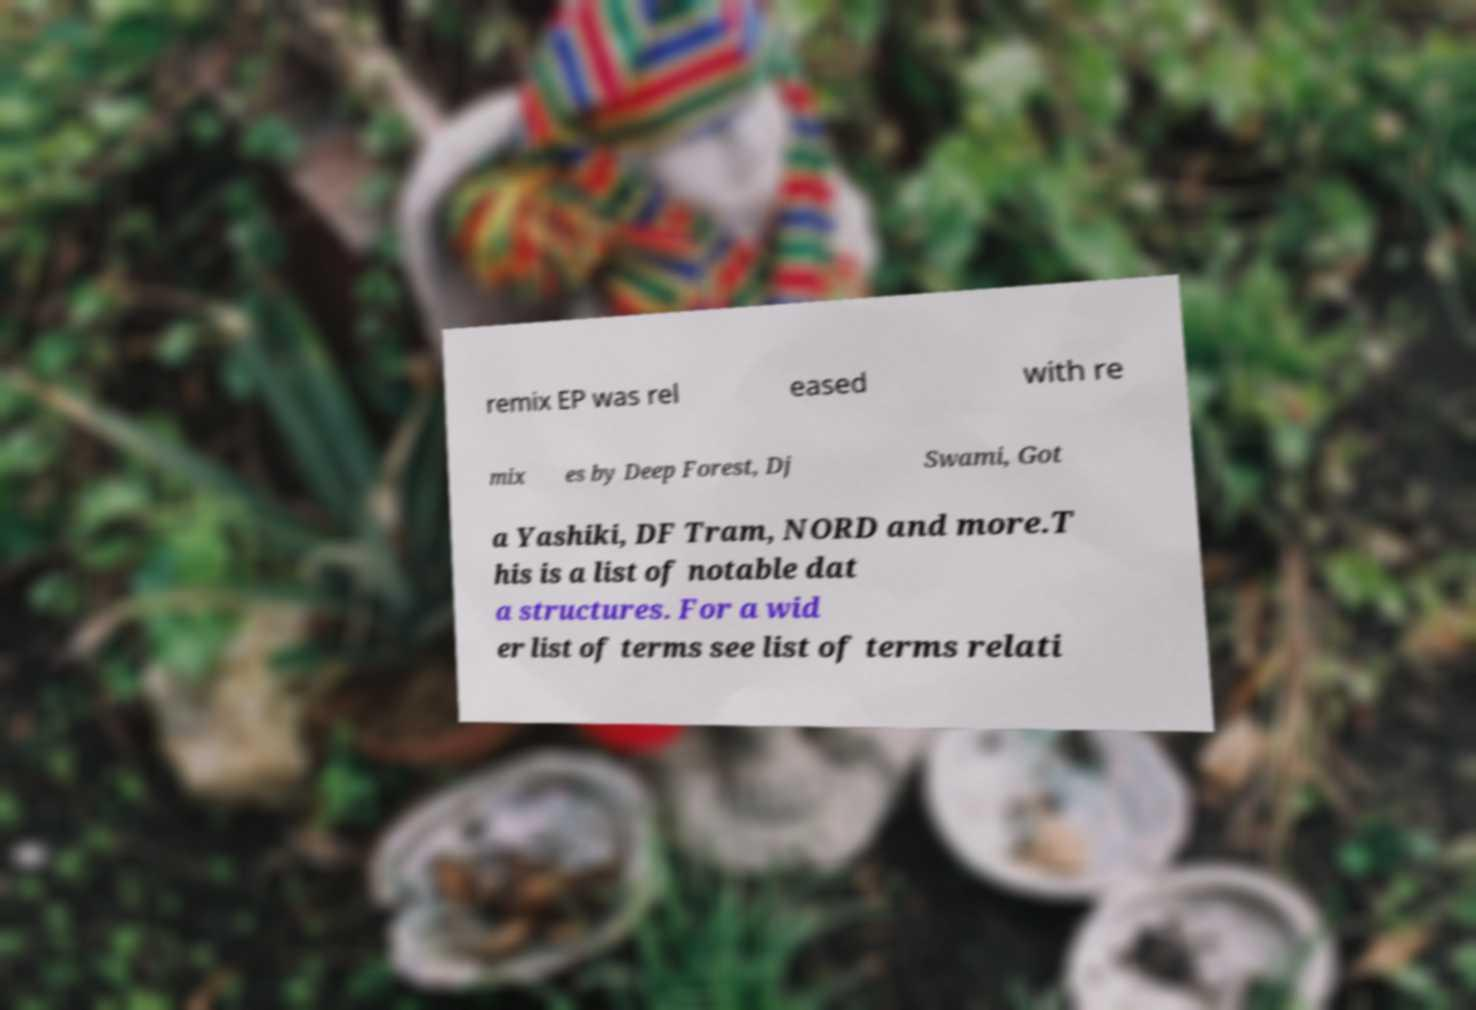For documentation purposes, I need the text within this image transcribed. Could you provide that? remix EP was rel eased with re mix es by Deep Forest, Dj Swami, Got a Yashiki, DF Tram, NORD and more.T his is a list of notable dat a structures. For a wid er list of terms see list of terms relati 